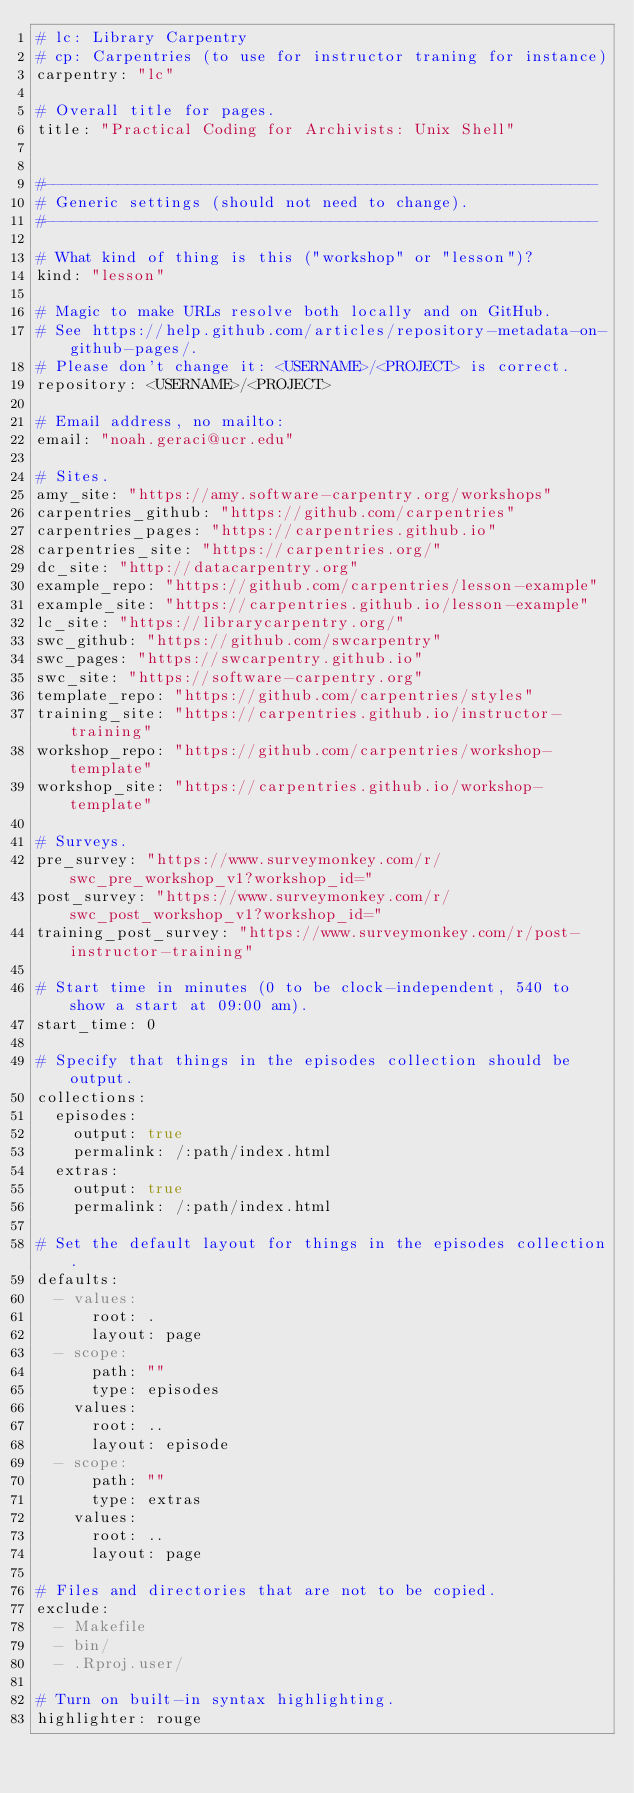Convert code to text. <code><loc_0><loc_0><loc_500><loc_500><_YAML_># lc: Library Carpentry
# cp: Carpentries (to use for instructor traning for instance)
carpentry: "lc"

# Overall title for pages.
title: "Practical Coding for Archivists: Unix Shell"


#------------------------------------------------------------
# Generic settings (should not need to change).
#------------------------------------------------------------

# What kind of thing is this ("workshop" or "lesson")?
kind: "lesson"

# Magic to make URLs resolve both locally and on GitHub.
# See https://help.github.com/articles/repository-metadata-on-github-pages/.
# Please don't change it: <USERNAME>/<PROJECT> is correct.
repository: <USERNAME>/<PROJECT>

# Email address, no mailto:
email: "noah.geraci@ucr.edu"

# Sites.
amy_site: "https://amy.software-carpentry.org/workshops"
carpentries_github: "https://github.com/carpentries"
carpentries_pages: "https://carpentries.github.io"
carpentries_site: "https://carpentries.org/"
dc_site: "http://datacarpentry.org"
example_repo: "https://github.com/carpentries/lesson-example"
example_site: "https://carpentries.github.io/lesson-example"
lc_site: "https://librarycarpentry.org/"
swc_github: "https://github.com/swcarpentry"
swc_pages: "https://swcarpentry.github.io"
swc_site: "https://software-carpentry.org"
template_repo: "https://github.com/carpentries/styles"
training_site: "https://carpentries.github.io/instructor-training"
workshop_repo: "https://github.com/carpentries/workshop-template"
workshop_site: "https://carpentries.github.io/workshop-template"

# Surveys.
pre_survey: "https://www.surveymonkey.com/r/swc_pre_workshop_v1?workshop_id="
post_survey: "https://www.surveymonkey.com/r/swc_post_workshop_v1?workshop_id="
training_post_survey: "https://www.surveymonkey.com/r/post-instructor-training"

# Start time in minutes (0 to be clock-independent, 540 to show a start at 09:00 am).
start_time: 0

# Specify that things in the episodes collection should be output.
collections:
  episodes:
    output: true
    permalink: /:path/index.html
  extras:
    output: true
    permalink: /:path/index.html

# Set the default layout for things in the episodes collection.
defaults:
  - values:
      root: .
      layout: page
  - scope:
      path: ""
      type: episodes
    values:
      root: ..
      layout: episode
  - scope:
      path: ""
      type: extras
    values:
      root: ..
      layout: page

# Files and directories that are not to be copied.
exclude:
  - Makefile
  - bin/
  - .Rproj.user/

# Turn on built-in syntax highlighting.
highlighter: rouge
</code> 